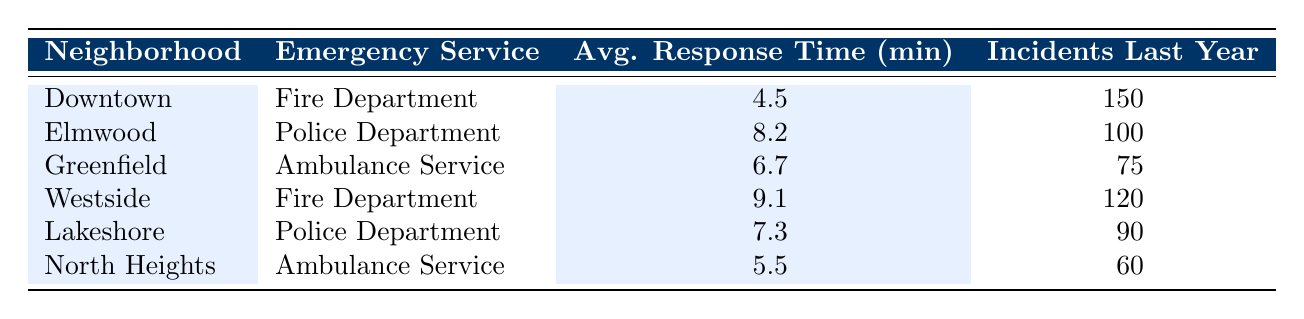What is the average response time of the Fire Department in Downtown? The data shows the average response time for the Fire Department in Downtown is listed as 4.5 minutes.
Answer: 4.5 Which neighborhood has the longest average response time? By looking at the table, Westside has the highest average response time, which is 9.1 minutes.
Answer: Westside How many incidents did the Police Department respond to in Elmwood last year? The table indicates that the Police Department had 100 incidents in Elmwood last year.
Answer: 100 What is the average response time for the Ambulance Service in North Heights? The table shows that the average response time for the Ambulance Service in North Heights is 5.5 minutes.
Answer: 5.5 Is the average response time for the Fire Department in Westside greater than 8 minutes? Yes, the average response time for the Fire Department in Westside is 9.1 minutes, which is greater than 8 minutes.
Answer: Yes What is the total number of incidents recorded by both Police Departments combined (Elmwood and Lakeshore)? The table states that Elmwood had 100 incidents and Lakeshore had 90 incidents. Adding these gives 100 + 90 = 190 incidents.
Answer: 190 Which emergency service in Greenfield has a higher response time than the average response time for Ambulance Services across all neighborhoods? In Greenfield, the Ambulance Service has an average response time of 6.7 minutes, which is higher than North Heights' 5.5 minutes but not compared to others. The average response is calculated as (4.5, 8.2, 6.7, 9.1, 7.3, 5.5), which is 6.6 minutes overall. Greenfield's time is 6.7, which is higher.
Answer: Yes What is the average response time for all services combined? To find the average, add up all the average response times: 4.5 + 8.2 + 6.7 + 9.1 + 7.3 + 5.5 = 41.3. The total number of services is 6, so the average is 41.3 / 6 = 6.88 minutes.
Answer: 6.88 